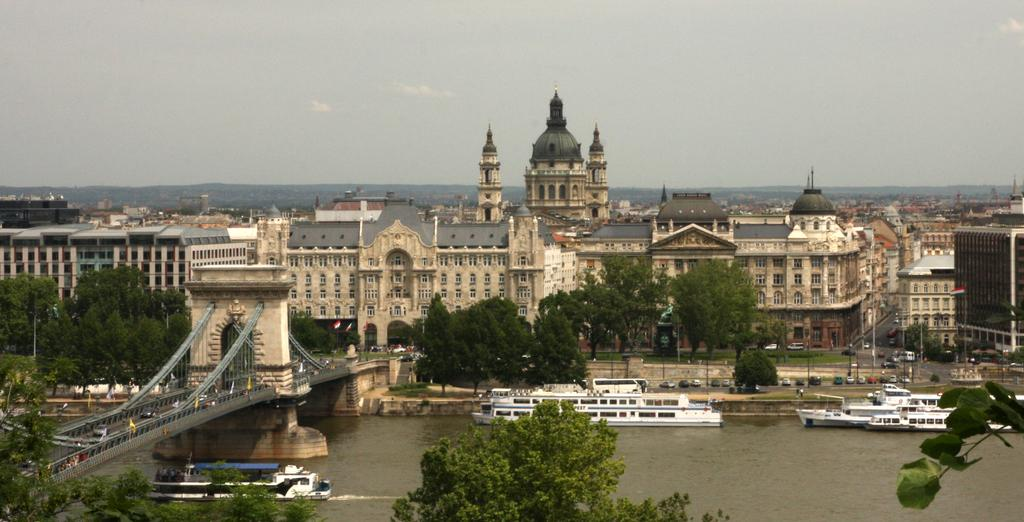What can be seen on the water in the image? There are ships on the water in the image. What structure is present in the image that connects two areas? There is a bridge in the image. What types of transportation are visible in the image? There are vehicles in the image. What color are the trees in the image? The trees have green color in the image. What colors are the buildings in the image? The buildings have white and cream colors in the image. What color is the sky in the image? The sky is in white color in the image. What holiday is being celebrated in the image? There is no indication of a holiday being celebrated in the image. Is there any evidence of war or conflict in the image? There is no evidence of war or conflict in the image. 